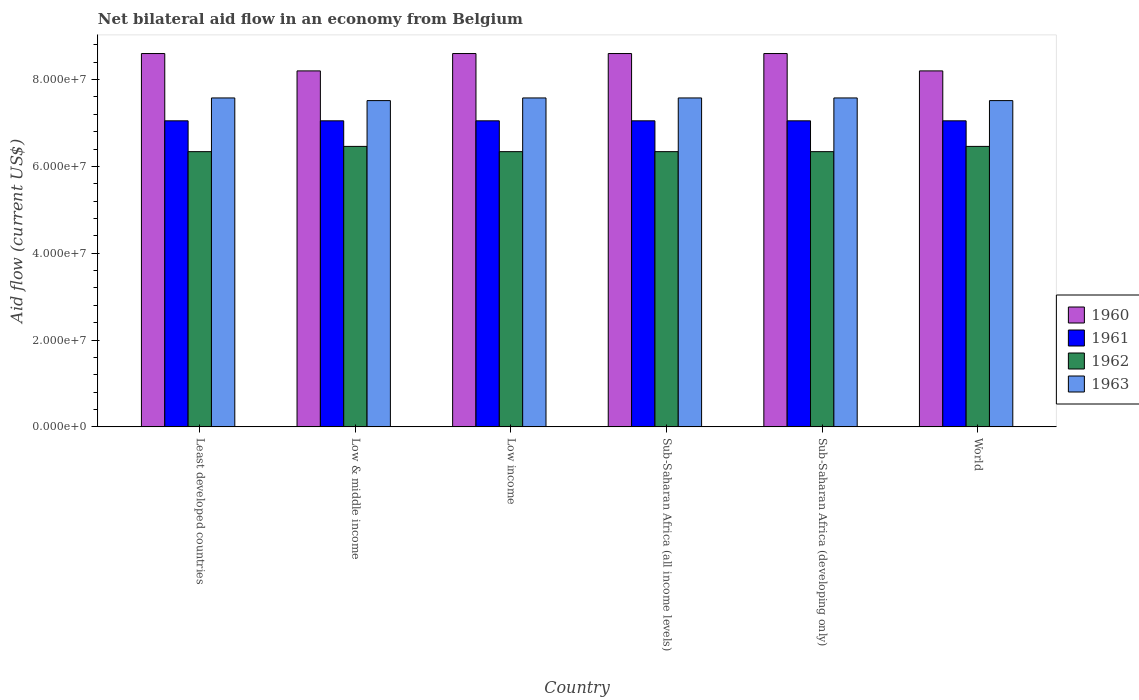Are the number of bars per tick equal to the number of legend labels?
Offer a terse response. Yes. Are the number of bars on each tick of the X-axis equal?
Ensure brevity in your answer.  Yes. How many bars are there on the 6th tick from the left?
Offer a very short reply. 4. How many bars are there on the 2nd tick from the right?
Provide a short and direct response. 4. What is the label of the 3rd group of bars from the left?
Provide a short and direct response. Low income. What is the net bilateral aid flow in 1962 in Least developed countries?
Provide a succinct answer. 6.34e+07. Across all countries, what is the maximum net bilateral aid flow in 1961?
Provide a short and direct response. 7.05e+07. Across all countries, what is the minimum net bilateral aid flow in 1960?
Your answer should be very brief. 8.20e+07. In which country was the net bilateral aid flow in 1960 maximum?
Your response must be concise. Least developed countries. In which country was the net bilateral aid flow in 1962 minimum?
Provide a short and direct response. Least developed countries. What is the total net bilateral aid flow in 1960 in the graph?
Offer a very short reply. 5.08e+08. What is the difference between the net bilateral aid flow in 1963 in Low income and the net bilateral aid flow in 1962 in Sub-Saharan Africa (developing only)?
Make the answer very short. 1.24e+07. What is the average net bilateral aid flow in 1961 per country?
Make the answer very short. 7.05e+07. What is the difference between the net bilateral aid flow of/in 1963 and net bilateral aid flow of/in 1960 in Sub-Saharan Africa (developing only)?
Ensure brevity in your answer.  -1.02e+07. What is the ratio of the net bilateral aid flow in 1963 in Low & middle income to that in Sub-Saharan Africa (all income levels)?
Ensure brevity in your answer.  0.99. Is the net bilateral aid flow in 1960 in Sub-Saharan Africa (all income levels) less than that in Sub-Saharan Africa (developing only)?
Give a very brief answer. No. What is the difference between the highest and the second highest net bilateral aid flow in 1962?
Offer a very short reply. 1.21e+06. What is the difference between the highest and the lowest net bilateral aid flow in 1963?
Keep it short and to the point. 6.10e+05. What does the 1st bar from the right in Sub-Saharan Africa (all income levels) represents?
Provide a short and direct response. 1963. How many bars are there?
Offer a very short reply. 24. Are all the bars in the graph horizontal?
Your response must be concise. No. Are the values on the major ticks of Y-axis written in scientific E-notation?
Offer a terse response. Yes. Does the graph contain any zero values?
Give a very brief answer. No. Where does the legend appear in the graph?
Your answer should be compact. Center right. How many legend labels are there?
Your response must be concise. 4. How are the legend labels stacked?
Keep it short and to the point. Vertical. What is the title of the graph?
Offer a terse response. Net bilateral aid flow in an economy from Belgium. What is the label or title of the Y-axis?
Keep it short and to the point. Aid flow (current US$). What is the Aid flow (current US$) in 1960 in Least developed countries?
Offer a very short reply. 8.60e+07. What is the Aid flow (current US$) of 1961 in Least developed countries?
Provide a short and direct response. 7.05e+07. What is the Aid flow (current US$) of 1962 in Least developed countries?
Your answer should be very brief. 6.34e+07. What is the Aid flow (current US$) of 1963 in Least developed countries?
Your answer should be compact. 7.58e+07. What is the Aid flow (current US$) of 1960 in Low & middle income?
Give a very brief answer. 8.20e+07. What is the Aid flow (current US$) in 1961 in Low & middle income?
Your answer should be compact. 7.05e+07. What is the Aid flow (current US$) of 1962 in Low & middle income?
Give a very brief answer. 6.46e+07. What is the Aid flow (current US$) in 1963 in Low & middle income?
Give a very brief answer. 7.52e+07. What is the Aid flow (current US$) of 1960 in Low income?
Give a very brief answer. 8.60e+07. What is the Aid flow (current US$) in 1961 in Low income?
Offer a very short reply. 7.05e+07. What is the Aid flow (current US$) of 1962 in Low income?
Your answer should be very brief. 6.34e+07. What is the Aid flow (current US$) in 1963 in Low income?
Make the answer very short. 7.58e+07. What is the Aid flow (current US$) in 1960 in Sub-Saharan Africa (all income levels)?
Ensure brevity in your answer.  8.60e+07. What is the Aid flow (current US$) in 1961 in Sub-Saharan Africa (all income levels)?
Provide a short and direct response. 7.05e+07. What is the Aid flow (current US$) of 1962 in Sub-Saharan Africa (all income levels)?
Provide a succinct answer. 6.34e+07. What is the Aid flow (current US$) of 1963 in Sub-Saharan Africa (all income levels)?
Provide a succinct answer. 7.58e+07. What is the Aid flow (current US$) of 1960 in Sub-Saharan Africa (developing only)?
Your response must be concise. 8.60e+07. What is the Aid flow (current US$) of 1961 in Sub-Saharan Africa (developing only)?
Provide a succinct answer. 7.05e+07. What is the Aid flow (current US$) in 1962 in Sub-Saharan Africa (developing only)?
Give a very brief answer. 6.34e+07. What is the Aid flow (current US$) of 1963 in Sub-Saharan Africa (developing only)?
Provide a succinct answer. 7.58e+07. What is the Aid flow (current US$) of 1960 in World?
Keep it short and to the point. 8.20e+07. What is the Aid flow (current US$) in 1961 in World?
Provide a short and direct response. 7.05e+07. What is the Aid flow (current US$) in 1962 in World?
Provide a succinct answer. 6.46e+07. What is the Aid flow (current US$) of 1963 in World?
Keep it short and to the point. 7.52e+07. Across all countries, what is the maximum Aid flow (current US$) in 1960?
Provide a short and direct response. 8.60e+07. Across all countries, what is the maximum Aid flow (current US$) of 1961?
Your response must be concise. 7.05e+07. Across all countries, what is the maximum Aid flow (current US$) in 1962?
Give a very brief answer. 6.46e+07. Across all countries, what is the maximum Aid flow (current US$) in 1963?
Provide a succinct answer. 7.58e+07. Across all countries, what is the minimum Aid flow (current US$) in 1960?
Provide a short and direct response. 8.20e+07. Across all countries, what is the minimum Aid flow (current US$) in 1961?
Your response must be concise. 7.05e+07. Across all countries, what is the minimum Aid flow (current US$) in 1962?
Keep it short and to the point. 6.34e+07. Across all countries, what is the minimum Aid flow (current US$) of 1963?
Make the answer very short. 7.52e+07. What is the total Aid flow (current US$) of 1960 in the graph?
Ensure brevity in your answer.  5.08e+08. What is the total Aid flow (current US$) of 1961 in the graph?
Keep it short and to the point. 4.23e+08. What is the total Aid flow (current US$) of 1962 in the graph?
Offer a terse response. 3.83e+08. What is the total Aid flow (current US$) of 1963 in the graph?
Your answer should be very brief. 4.53e+08. What is the difference between the Aid flow (current US$) in 1960 in Least developed countries and that in Low & middle income?
Your response must be concise. 4.00e+06. What is the difference between the Aid flow (current US$) of 1962 in Least developed countries and that in Low & middle income?
Your answer should be very brief. -1.21e+06. What is the difference between the Aid flow (current US$) in 1963 in Least developed countries and that in Low & middle income?
Ensure brevity in your answer.  6.10e+05. What is the difference between the Aid flow (current US$) of 1962 in Least developed countries and that in Low income?
Provide a succinct answer. 0. What is the difference between the Aid flow (current US$) in 1963 in Least developed countries and that in Low income?
Give a very brief answer. 0. What is the difference between the Aid flow (current US$) in 1961 in Least developed countries and that in Sub-Saharan Africa (all income levels)?
Your answer should be very brief. 0. What is the difference between the Aid flow (current US$) of 1962 in Least developed countries and that in Sub-Saharan Africa (all income levels)?
Ensure brevity in your answer.  0. What is the difference between the Aid flow (current US$) of 1963 in Least developed countries and that in Sub-Saharan Africa (all income levels)?
Offer a very short reply. 0. What is the difference between the Aid flow (current US$) of 1962 in Least developed countries and that in Sub-Saharan Africa (developing only)?
Offer a very short reply. 0. What is the difference between the Aid flow (current US$) in 1961 in Least developed countries and that in World?
Give a very brief answer. 0. What is the difference between the Aid flow (current US$) in 1962 in Least developed countries and that in World?
Offer a terse response. -1.21e+06. What is the difference between the Aid flow (current US$) of 1963 in Least developed countries and that in World?
Make the answer very short. 6.10e+05. What is the difference between the Aid flow (current US$) of 1962 in Low & middle income and that in Low income?
Offer a terse response. 1.21e+06. What is the difference between the Aid flow (current US$) in 1963 in Low & middle income and that in Low income?
Keep it short and to the point. -6.10e+05. What is the difference between the Aid flow (current US$) in 1960 in Low & middle income and that in Sub-Saharan Africa (all income levels)?
Your response must be concise. -4.00e+06. What is the difference between the Aid flow (current US$) in 1962 in Low & middle income and that in Sub-Saharan Africa (all income levels)?
Your answer should be very brief. 1.21e+06. What is the difference between the Aid flow (current US$) of 1963 in Low & middle income and that in Sub-Saharan Africa (all income levels)?
Offer a very short reply. -6.10e+05. What is the difference between the Aid flow (current US$) of 1960 in Low & middle income and that in Sub-Saharan Africa (developing only)?
Keep it short and to the point. -4.00e+06. What is the difference between the Aid flow (current US$) in 1962 in Low & middle income and that in Sub-Saharan Africa (developing only)?
Your answer should be very brief. 1.21e+06. What is the difference between the Aid flow (current US$) of 1963 in Low & middle income and that in Sub-Saharan Africa (developing only)?
Offer a terse response. -6.10e+05. What is the difference between the Aid flow (current US$) in 1960 in Low & middle income and that in World?
Your response must be concise. 0. What is the difference between the Aid flow (current US$) in 1961 in Low & middle income and that in World?
Your response must be concise. 0. What is the difference between the Aid flow (current US$) of 1962 in Low & middle income and that in World?
Ensure brevity in your answer.  0. What is the difference between the Aid flow (current US$) of 1961 in Low income and that in Sub-Saharan Africa (developing only)?
Keep it short and to the point. 0. What is the difference between the Aid flow (current US$) of 1960 in Low income and that in World?
Provide a short and direct response. 4.00e+06. What is the difference between the Aid flow (current US$) of 1961 in Low income and that in World?
Make the answer very short. 0. What is the difference between the Aid flow (current US$) of 1962 in Low income and that in World?
Your answer should be compact. -1.21e+06. What is the difference between the Aid flow (current US$) of 1963 in Low income and that in World?
Ensure brevity in your answer.  6.10e+05. What is the difference between the Aid flow (current US$) in 1962 in Sub-Saharan Africa (all income levels) and that in Sub-Saharan Africa (developing only)?
Keep it short and to the point. 0. What is the difference between the Aid flow (current US$) in 1960 in Sub-Saharan Africa (all income levels) and that in World?
Keep it short and to the point. 4.00e+06. What is the difference between the Aid flow (current US$) of 1961 in Sub-Saharan Africa (all income levels) and that in World?
Provide a succinct answer. 0. What is the difference between the Aid flow (current US$) of 1962 in Sub-Saharan Africa (all income levels) and that in World?
Keep it short and to the point. -1.21e+06. What is the difference between the Aid flow (current US$) in 1963 in Sub-Saharan Africa (all income levels) and that in World?
Make the answer very short. 6.10e+05. What is the difference between the Aid flow (current US$) of 1960 in Sub-Saharan Africa (developing only) and that in World?
Keep it short and to the point. 4.00e+06. What is the difference between the Aid flow (current US$) in 1962 in Sub-Saharan Africa (developing only) and that in World?
Your response must be concise. -1.21e+06. What is the difference between the Aid flow (current US$) of 1960 in Least developed countries and the Aid flow (current US$) of 1961 in Low & middle income?
Give a very brief answer. 1.55e+07. What is the difference between the Aid flow (current US$) of 1960 in Least developed countries and the Aid flow (current US$) of 1962 in Low & middle income?
Offer a terse response. 2.14e+07. What is the difference between the Aid flow (current US$) in 1960 in Least developed countries and the Aid flow (current US$) in 1963 in Low & middle income?
Your answer should be compact. 1.08e+07. What is the difference between the Aid flow (current US$) in 1961 in Least developed countries and the Aid flow (current US$) in 1962 in Low & middle income?
Ensure brevity in your answer.  5.89e+06. What is the difference between the Aid flow (current US$) in 1961 in Least developed countries and the Aid flow (current US$) in 1963 in Low & middle income?
Offer a terse response. -4.66e+06. What is the difference between the Aid flow (current US$) of 1962 in Least developed countries and the Aid flow (current US$) of 1963 in Low & middle income?
Make the answer very short. -1.18e+07. What is the difference between the Aid flow (current US$) of 1960 in Least developed countries and the Aid flow (current US$) of 1961 in Low income?
Your answer should be compact. 1.55e+07. What is the difference between the Aid flow (current US$) of 1960 in Least developed countries and the Aid flow (current US$) of 1962 in Low income?
Offer a very short reply. 2.26e+07. What is the difference between the Aid flow (current US$) of 1960 in Least developed countries and the Aid flow (current US$) of 1963 in Low income?
Provide a short and direct response. 1.02e+07. What is the difference between the Aid flow (current US$) of 1961 in Least developed countries and the Aid flow (current US$) of 1962 in Low income?
Your answer should be very brief. 7.10e+06. What is the difference between the Aid flow (current US$) in 1961 in Least developed countries and the Aid flow (current US$) in 1963 in Low income?
Your answer should be compact. -5.27e+06. What is the difference between the Aid flow (current US$) of 1962 in Least developed countries and the Aid flow (current US$) of 1963 in Low income?
Your answer should be compact. -1.24e+07. What is the difference between the Aid flow (current US$) in 1960 in Least developed countries and the Aid flow (current US$) in 1961 in Sub-Saharan Africa (all income levels)?
Your response must be concise. 1.55e+07. What is the difference between the Aid flow (current US$) of 1960 in Least developed countries and the Aid flow (current US$) of 1962 in Sub-Saharan Africa (all income levels)?
Make the answer very short. 2.26e+07. What is the difference between the Aid flow (current US$) of 1960 in Least developed countries and the Aid flow (current US$) of 1963 in Sub-Saharan Africa (all income levels)?
Keep it short and to the point. 1.02e+07. What is the difference between the Aid flow (current US$) in 1961 in Least developed countries and the Aid flow (current US$) in 1962 in Sub-Saharan Africa (all income levels)?
Ensure brevity in your answer.  7.10e+06. What is the difference between the Aid flow (current US$) of 1961 in Least developed countries and the Aid flow (current US$) of 1963 in Sub-Saharan Africa (all income levels)?
Keep it short and to the point. -5.27e+06. What is the difference between the Aid flow (current US$) of 1962 in Least developed countries and the Aid flow (current US$) of 1963 in Sub-Saharan Africa (all income levels)?
Give a very brief answer. -1.24e+07. What is the difference between the Aid flow (current US$) of 1960 in Least developed countries and the Aid flow (current US$) of 1961 in Sub-Saharan Africa (developing only)?
Provide a short and direct response. 1.55e+07. What is the difference between the Aid flow (current US$) in 1960 in Least developed countries and the Aid flow (current US$) in 1962 in Sub-Saharan Africa (developing only)?
Offer a terse response. 2.26e+07. What is the difference between the Aid flow (current US$) in 1960 in Least developed countries and the Aid flow (current US$) in 1963 in Sub-Saharan Africa (developing only)?
Provide a short and direct response. 1.02e+07. What is the difference between the Aid flow (current US$) in 1961 in Least developed countries and the Aid flow (current US$) in 1962 in Sub-Saharan Africa (developing only)?
Provide a short and direct response. 7.10e+06. What is the difference between the Aid flow (current US$) of 1961 in Least developed countries and the Aid flow (current US$) of 1963 in Sub-Saharan Africa (developing only)?
Your answer should be compact. -5.27e+06. What is the difference between the Aid flow (current US$) of 1962 in Least developed countries and the Aid flow (current US$) of 1963 in Sub-Saharan Africa (developing only)?
Offer a very short reply. -1.24e+07. What is the difference between the Aid flow (current US$) of 1960 in Least developed countries and the Aid flow (current US$) of 1961 in World?
Ensure brevity in your answer.  1.55e+07. What is the difference between the Aid flow (current US$) in 1960 in Least developed countries and the Aid flow (current US$) in 1962 in World?
Make the answer very short. 2.14e+07. What is the difference between the Aid flow (current US$) in 1960 in Least developed countries and the Aid flow (current US$) in 1963 in World?
Provide a succinct answer. 1.08e+07. What is the difference between the Aid flow (current US$) in 1961 in Least developed countries and the Aid flow (current US$) in 1962 in World?
Provide a short and direct response. 5.89e+06. What is the difference between the Aid flow (current US$) of 1961 in Least developed countries and the Aid flow (current US$) of 1963 in World?
Ensure brevity in your answer.  -4.66e+06. What is the difference between the Aid flow (current US$) of 1962 in Least developed countries and the Aid flow (current US$) of 1963 in World?
Keep it short and to the point. -1.18e+07. What is the difference between the Aid flow (current US$) of 1960 in Low & middle income and the Aid flow (current US$) of 1961 in Low income?
Provide a short and direct response. 1.15e+07. What is the difference between the Aid flow (current US$) of 1960 in Low & middle income and the Aid flow (current US$) of 1962 in Low income?
Your answer should be very brief. 1.86e+07. What is the difference between the Aid flow (current US$) in 1960 in Low & middle income and the Aid flow (current US$) in 1963 in Low income?
Provide a short and direct response. 6.23e+06. What is the difference between the Aid flow (current US$) of 1961 in Low & middle income and the Aid flow (current US$) of 1962 in Low income?
Provide a short and direct response. 7.10e+06. What is the difference between the Aid flow (current US$) in 1961 in Low & middle income and the Aid flow (current US$) in 1963 in Low income?
Ensure brevity in your answer.  -5.27e+06. What is the difference between the Aid flow (current US$) of 1962 in Low & middle income and the Aid flow (current US$) of 1963 in Low income?
Your response must be concise. -1.12e+07. What is the difference between the Aid flow (current US$) of 1960 in Low & middle income and the Aid flow (current US$) of 1961 in Sub-Saharan Africa (all income levels)?
Give a very brief answer. 1.15e+07. What is the difference between the Aid flow (current US$) in 1960 in Low & middle income and the Aid flow (current US$) in 1962 in Sub-Saharan Africa (all income levels)?
Your answer should be very brief. 1.86e+07. What is the difference between the Aid flow (current US$) in 1960 in Low & middle income and the Aid flow (current US$) in 1963 in Sub-Saharan Africa (all income levels)?
Your response must be concise. 6.23e+06. What is the difference between the Aid flow (current US$) in 1961 in Low & middle income and the Aid flow (current US$) in 1962 in Sub-Saharan Africa (all income levels)?
Give a very brief answer. 7.10e+06. What is the difference between the Aid flow (current US$) of 1961 in Low & middle income and the Aid flow (current US$) of 1963 in Sub-Saharan Africa (all income levels)?
Ensure brevity in your answer.  -5.27e+06. What is the difference between the Aid flow (current US$) of 1962 in Low & middle income and the Aid flow (current US$) of 1963 in Sub-Saharan Africa (all income levels)?
Keep it short and to the point. -1.12e+07. What is the difference between the Aid flow (current US$) in 1960 in Low & middle income and the Aid flow (current US$) in 1961 in Sub-Saharan Africa (developing only)?
Keep it short and to the point. 1.15e+07. What is the difference between the Aid flow (current US$) in 1960 in Low & middle income and the Aid flow (current US$) in 1962 in Sub-Saharan Africa (developing only)?
Provide a short and direct response. 1.86e+07. What is the difference between the Aid flow (current US$) of 1960 in Low & middle income and the Aid flow (current US$) of 1963 in Sub-Saharan Africa (developing only)?
Make the answer very short. 6.23e+06. What is the difference between the Aid flow (current US$) in 1961 in Low & middle income and the Aid flow (current US$) in 1962 in Sub-Saharan Africa (developing only)?
Offer a very short reply. 7.10e+06. What is the difference between the Aid flow (current US$) of 1961 in Low & middle income and the Aid flow (current US$) of 1963 in Sub-Saharan Africa (developing only)?
Give a very brief answer. -5.27e+06. What is the difference between the Aid flow (current US$) in 1962 in Low & middle income and the Aid flow (current US$) in 1963 in Sub-Saharan Africa (developing only)?
Provide a succinct answer. -1.12e+07. What is the difference between the Aid flow (current US$) of 1960 in Low & middle income and the Aid flow (current US$) of 1961 in World?
Your answer should be compact. 1.15e+07. What is the difference between the Aid flow (current US$) of 1960 in Low & middle income and the Aid flow (current US$) of 1962 in World?
Provide a succinct answer. 1.74e+07. What is the difference between the Aid flow (current US$) in 1960 in Low & middle income and the Aid flow (current US$) in 1963 in World?
Your answer should be very brief. 6.84e+06. What is the difference between the Aid flow (current US$) in 1961 in Low & middle income and the Aid flow (current US$) in 1962 in World?
Provide a short and direct response. 5.89e+06. What is the difference between the Aid flow (current US$) in 1961 in Low & middle income and the Aid flow (current US$) in 1963 in World?
Make the answer very short. -4.66e+06. What is the difference between the Aid flow (current US$) of 1962 in Low & middle income and the Aid flow (current US$) of 1963 in World?
Make the answer very short. -1.06e+07. What is the difference between the Aid flow (current US$) of 1960 in Low income and the Aid flow (current US$) of 1961 in Sub-Saharan Africa (all income levels)?
Provide a succinct answer. 1.55e+07. What is the difference between the Aid flow (current US$) of 1960 in Low income and the Aid flow (current US$) of 1962 in Sub-Saharan Africa (all income levels)?
Your answer should be very brief. 2.26e+07. What is the difference between the Aid flow (current US$) in 1960 in Low income and the Aid flow (current US$) in 1963 in Sub-Saharan Africa (all income levels)?
Make the answer very short. 1.02e+07. What is the difference between the Aid flow (current US$) in 1961 in Low income and the Aid flow (current US$) in 1962 in Sub-Saharan Africa (all income levels)?
Your answer should be compact. 7.10e+06. What is the difference between the Aid flow (current US$) of 1961 in Low income and the Aid flow (current US$) of 1963 in Sub-Saharan Africa (all income levels)?
Your answer should be very brief. -5.27e+06. What is the difference between the Aid flow (current US$) in 1962 in Low income and the Aid flow (current US$) in 1963 in Sub-Saharan Africa (all income levels)?
Offer a very short reply. -1.24e+07. What is the difference between the Aid flow (current US$) in 1960 in Low income and the Aid flow (current US$) in 1961 in Sub-Saharan Africa (developing only)?
Offer a terse response. 1.55e+07. What is the difference between the Aid flow (current US$) in 1960 in Low income and the Aid flow (current US$) in 1962 in Sub-Saharan Africa (developing only)?
Provide a short and direct response. 2.26e+07. What is the difference between the Aid flow (current US$) in 1960 in Low income and the Aid flow (current US$) in 1963 in Sub-Saharan Africa (developing only)?
Offer a very short reply. 1.02e+07. What is the difference between the Aid flow (current US$) of 1961 in Low income and the Aid flow (current US$) of 1962 in Sub-Saharan Africa (developing only)?
Give a very brief answer. 7.10e+06. What is the difference between the Aid flow (current US$) in 1961 in Low income and the Aid flow (current US$) in 1963 in Sub-Saharan Africa (developing only)?
Your answer should be very brief. -5.27e+06. What is the difference between the Aid flow (current US$) in 1962 in Low income and the Aid flow (current US$) in 1963 in Sub-Saharan Africa (developing only)?
Give a very brief answer. -1.24e+07. What is the difference between the Aid flow (current US$) in 1960 in Low income and the Aid flow (current US$) in 1961 in World?
Your response must be concise. 1.55e+07. What is the difference between the Aid flow (current US$) in 1960 in Low income and the Aid flow (current US$) in 1962 in World?
Offer a very short reply. 2.14e+07. What is the difference between the Aid flow (current US$) of 1960 in Low income and the Aid flow (current US$) of 1963 in World?
Your answer should be compact. 1.08e+07. What is the difference between the Aid flow (current US$) in 1961 in Low income and the Aid flow (current US$) in 1962 in World?
Give a very brief answer. 5.89e+06. What is the difference between the Aid flow (current US$) in 1961 in Low income and the Aid flow (current US$) in 1963 in World?
Make the answer very short. -4.66e+06. What is the difference between the Aid flow (current US$) in 1962 in Low income and the Aid flow (current US$) in 1963 in World?
Make the answer very short. -1.18e+07. What is the difference between the Aid flow (current US$) in 1960 in Sub-Saharan Africa (all income levels) and the Aid flow (current US$) in 1961 in Sub-Saharan Africa (developing only)?
Give a very brief answer. 1.55e+07. What is the difference between the Aid flow (current US$) in 1960 in Sub-Saharan Africa (all income levels) and the Aid flow (current US$) in 1962 in Sub-Saharan Africa (developing only)?
Your response must be concise. 2.26e+07. What is the difference between the Aid flow (current US$) of 1960 in Sub-Saharan Africa (all income levels) and the Aid flow (current US$) of 1963 in Sub-Saharan Africa (developing only)?
Your answer should be very brief. 1.02e+07. What is the difference between the Aid flow (current US$) in 1961 in Sub-Saharan Africa (all income levels) and the Aid flow (current US$) in 1962 in Sub-Saharan Africa (developing only)?
Provide a short and direct response. 7.10e+06. What is the difference between the Aid flow (current US$) in 1961 in Sub-Saharan Africa (all income levels) and the Aid flow (current US$) in 1963 in Sub-Saharan Africa (developing only)?
Offer a terse response. -5.27e+06. What is the difference between the Aid flow (current US$) in 1962 in Sub-Saharan Africa (all income levels) and the Aid flow (current US$) in 1963 in Sub-Saharan Africa (developing only)?
Make the answer very short. -1.24e+07. What is the difference between the Aid flow (current US$) in 1960 in Sub-Saharan Africa (all income levels) and the Aid flow (current US$) in 1961 in World?
Provide a short and direct response. 1.55e+07. What is the difference between the Aid flow (current US$) in 1960 in Sub-Saharan Africa (all income levels) and the Aid flow (current US$) in 1962 in World?
Your answer should be compact. 2.14e+07. What is the difference between the Aid flow (current US$) of 1960 in Sub-Saharan Africa (all income levels) and the Aid flow (current US$) of 1963 in World?
Give a very brief answer. 1.08e+07. What is the difference between the Aid flow (current US$) of 1961 in Sub-Saharan Africa (all income levels) and the Aid flow (current US$) of 1962 in World?
Your response must be concise. 5.89e+06. What is the difference between the Aid flow (current US$) in 1961 in Sub-Saharan Africa (all income levels) and the Aid flow (current US$) in 1963 in World?
Provide a succinct answer. -4.66e+06. What is the difference between the Aid flow (current US$) of 1962 in Sub-Saharan Africa (all income levels) and the Aid flow (current US$) of 1963 in World?
Provide a short and direct response. -1.18e+07. What is the difference between the Aid flow (current US$) of 1960 in Sub-Saharan Africa (developing only) and the Aid flow (current US$) of 1961 in World?
Provide a succinct answer. 1.55e+07. What is the difference between the Aid flow (current US$) in 1960 in Sub-Saharan Africa (developing only) and the Aid flow (current US$) in 1962 in World?
Offer a very short reply. 2.14e+07. What is the difference between the Aid flow (current US$) of 1960 in Sub-Saharan Africa (developing only) and the Aid flow (current US$) of 1963 in World?
Offer a terse response. 1.08e+07. What is the difference between the Aid flow (current US$) of 1961 in Sub-Saharan Africa (developing only) and the Aid flow (current US$) of 1962 in World?
Your answer should be compact. 5.89e+06. What is the difference between the Aid flow (current US$) in 1961 in Sub-Saharan Africa (developing only) and the Aid flow (current US$) in 1963 in World?
Keep it short and to the point. -4.66e+06. What is the difference between the Aid flow (current US$) in 1962 in Sub-Saharan Africa (developing only) and the Aid flow (current US$) in 1963 in World?
Provide a short and direct response. -1.18e+07. What is the average Aid flow (current US$) of 1960 per country?
Ensure brevity in your answer.  8.47e+07. What is the average Aid flow (current US$) of 1961 per country?
Provide a short and direct response. 7.05e+07. What is the average Aid flow (current US$) in 1962 per country?
Ensure brevity in your answer.  6.38e+07. What is the average Aid flow (current US$) of 1963 per country?
Make the answer very short. 7.56e+07. What is the difference between the Aid flow (current US$) of 1960 and Aid flow (current US$) of 1961 in Least developed countries?
Ensure brevity in your answer.  1.55e+07. What is the difference between the Aid flow (current US$) of 1960 and Aid flow (current US$) of 1962 in Least developed countries?
Give a very brief answer. 2.26e+07. What is the difference between the Aid flow (current US$) of 1960 and Aid flow (current US$) of 1963 in Least developed countries?
Offer a terse response. 1.02e+07. What is the difference between the Aid flow (current US$) of 1961 and Aid flow (current US$) of 1962 in Least developed countries?
Provide a short and direct response. 7.10e+06. What is the difference between the Aid flow (current US$) in 1961 and Aid flow (current US$) in 1963 in Least developed countries?
Offer a terse response. -5.27e+06. What is the difference between the Aid flow (current US$) in 1962 and Aid flow (current US$) in 1963 in Least developed countries?
Your response must be concise. -1.24e+07. What is the difference between the Aid flow (current US$) of 1960 and Aid flow (current US$) of 1961 in Low & middle income?
Ensure brevity in your answer.  1.15e+07. What is the difference between the Aid flow (current US$) of 1960 and Aid flow (current US$) of 1962 in Low & middle income?
Offer a very short reply. 1.74e+07. What is the difference between the Aid flow (current US$) of 1960 and Aid flow (current US$) of 1963 in Low & middle income?
Make the answer very short. 6.84e+06. What is the difference between the Aid flow (current US$) in 1961 and Aid flow (current US$) in 1962 in Low & middle income?
Offer a terse response. 5.89e+06. What is the difference between the Aid flow (current US$) in 1961 and Aid flow (current US$) in 1963 in Low & middle income?
Provide a short and direct response. -4.66e+06. What is the difference between the Aid flow (current US$) in 1962 and Aid flow (current US$) in 1963 in Low & middle income?
Ensure brevity in your answer.  -1.06e+07. What is the difference between the Aid flow (current US$) in 1960 and Aid flow (current US$) in 1961 in Low income?
Provide a short and direct response. 1.55e+07. What is the difference between the Aid flow (current US$) in 1960 and Aid flow (current US$) in 1962 in Low income?
Keep it short and to the point. 2.26e+07. What is the difference between the Aid flow (current US$) in 1960 and Aid flow (current US$) in 1963 in Low income?
Give a very brief answer. 1.02e+07. What is the difference between the Aid flow (current US$) in 1961 and Aid flow (current US$) in 1962 in Low income?
Give a very brief answer. 7.10e+06. What is the difference between the Aid flow (current US$) in 1961 and Aid flow (current US$) in 1963 in Low income?
Keep it short and to the point. -5.27e+06. What is the difference between the Aid flow (current US$) in 1962 and Aid flow (current US$) in 1963 in Low income?
Your answer should be very brief. -1.24e+07. What is the difference between the Aid flow (current US$) in 1960 and Aid flow (current US$) in 1961 in Sub-Saharan Africa (all income levels)?
Keep it short and to the point. 1.55e+07. What is the difference between the Aid flow (current US$) in 1960 and Aid flow (current US$) in 1962 in Sub-Saharan Africa (all income levels)?
Your answer should be compact. 2.26e+07. What is the difference between the Aid flow (current US$) of 1960 and Aid flow (current US$) of 1963 in Sub-Saharan Africa (all income levels)?
Ensure brevity in your answer.  1.02e+07. What is the difference between the Aid flow (current US$) of 1961 and Aid flow (current US$) of 1962 in Sub-Saharan Africa (all income levels)?
Keep it short and to the point. 7.10e+06. What is the difference between the Aid flow (current US$) of 1961 and Aid flow (current US$) of 1963 in Sub-Saharan Africa (all income levels)?
Your answer should be very brief. -5.27e+06. What is the difference between the Aid flow (current US$) of 1962 and Aid flow (current US$) of 1963 in Sub-Saharan Africa (all income levels)?
Keep it short and to the point. -1.24e+07. What is the difference between the Aid flow (current US$) in 1960 and Aid flow (current US$) in 1961 in Sub-Saharan Africa (developing only)?
Your answer should be very brief. 1.55e+07. What is the difference between the Aid flow (current US$) in 1960 and Aid flow (current US$) in 1962 in Sub-Saharan Africa (developing only)?
Give a very brief answer. 2.26e+07. What is the difference between the Aid flow (current US$) in 1960 and Aid flow (current US$) in 1963 in Sub-Saharan Africa (developing only)?
Provide a short and direct response. 1.02e+07. What is the difference between the Aid flow (current US$) of 1961 and Aid flow (current US$) of 1962 in Sub-Saharan Africa (developing only)?
Ensure brevity in your answer.  7.10e+06. What is the difference between the Aid flow (current US$) in 1961 and Aid flow (current US$) in 1963 in Sub-Saharan Africa (developing only)?
Ensure brevity in your answer.  -5.27e+06. What is the difference between the Aid flow (current US$) in 1962 and Aid flow (current US$) in 1963 in Sub-Saharan Africa (developing only)?
Provide a succinct answer. -1.24e+07. What is the difference between the Aid flow (current US$) in 1960 and Aid flow (current US$) in 1961 in World?
Your answer should be very brief. 1.15e+07. What is the difference between the Aid flow (current US$) of 1960 and Aid flow (current US$) of 1962 in World?
Your answer should be compact. 1.74e+07. What is the difference between the Aid flow (current US$) in 1960 and Aid flow (current US$) in 1963 in World?
Offer a very short reply. 6.84e+06. What is the difference between the Aid flow (current US$) in 1961 and Aid flow (current US$) in 1962 in World?
Your answer should be compact. 5.89e+06. What is the difference between the Aid flow (current US$) of 1961 and Aid flow (current US$) of 1963 in World?
Your answer should be compact. -4.66e+06. What is the difference between the Aid flow (current US$) in 1962 and Aid flow (current US$) in 1963 in World?
Your answer should be compact. -1.06e+07. What is the ratio of the Aid flow (current US$) in 1960 in Least developed countries to that in Low & middle income?
Offer a terse response. 1.05. What is the ratio of the Aid flow (current US$) of 1962 in Least developed countries to that in Low & middle income?
Your answer should be very brief. 0.98. What is the ratio of the Aid flow (current US$) of 1961 in Least developed countries to that in Low income?
Offer a very short reply. 1. What is the ratio of the Aid flow (current US$) of 1962 in Least developed countries to that in Low income?
Provide a short and direct response. 1. What is the ratio of the Aid flow (current US$) of 1963 in Least developed countries to that in Low income?
Make the answer very short. 1. What is the ratio of the Aid flow (current US$) in 1961 in Least developed countries to that in Sub-Saharan Africa (all income levels)?
Offer a terse response. 1. What is the ratio of the Aid flow (current US$) of 1962 in Least developed countries to that in Sub-Saharan Africa (all income levels)?
Your answer should be very brief. 1. What is the ratio of the Aid flow (current US$) in 1960 in Least developed countries to that in Sub-Saharan Africa (developing only)?
Your response must be concise. 1. What is the ratio of the Aid flow (current US$) of 1961 in Least developed countries to that in Sub-Saharan Africa (developing only)?
Provide a succinct answer. 1. What is the ratio of the Aid flow (current US$) of 1962 in Least developed countries to that in Sub-Saharan Africa (developing only)?
Your response must be concise. 1. What is the ratio of the Aid flow (current US$) in 1963 in Least developed countries to that in Sub-Saharan Africa (developing only)?
Make the answer very short. 1. What is the ratio of the Aid flow (current US$) in 1960 in Least developed countries to that in World?
Make the answer very short. 1.05. What is the ratio of the Aid flow (current US$) in 1962 in Least developed countries to that in World?
Make the answer very short. 0.98. What is the ratio of the Aid flow (current US$) in 1963 in Least developed countries to that in World?
Make the answer very short. 1.01. What is the ratio of the Aid flow (current US$) in 1960 in Low & middle income to that in Low income?
Give a very brief answer. 0.95. What is the ratio of the Aid flow (current US$) of 1962 in Low & middle income to that in Low income?
Give a very brief answer. 1.02. What is the ratio of the Aid flow (current US$) of 1960 in Low & middle income to that in Sub-Saharan Africa (all income levels)?
Your response must be concise. 0.95. What is the ratio of the Aid flow (current US$) in 1961 in Low & middle income to that in Sub-Saharan Africa (all income levels)?
Your answer should be compact. 1. What is the ratio of the Aid flow (current US$) in 1962 in Low & middle income to that in Sub-Saharan Africa (all income levels)?
Provide a short and direct response. 1.02. What is the ratio of the Aid flow (current US$) in 1963 in Low & middle income to that in Sub-Saharan Africa (all income levels)?
Your answer should be very brief. 0.99. What is the ratio of the Aid flow (current US$) of 1960 in Low & middle income to that in Sub-Saharan Africa (developing only)?
Make the answer very short. 0.95. What is the ratio of the Aid flow (current US$) in 1961 in Low & middle income to that in Sub-Saharan Africa (developing only)?
Keep it short and to the point. 1. What is the ratio of the Aid flow (current US$) of 1962 in Low & middle income to that in Sub-Saharan Africa (developing only)?
Provide a short and direct response. 1.02. What is the ratio of the Aid flow (current US$) of 1962 in Low & middle income to that in World?
Your answer should be very brief. 1. What is the ratio of the Aid flow (current US$) in 1960 in Low income to that in Sub-Saharan Africa (all income levels)?
Keep it short and to the point. 1. What is the ratio of the Aid flow (current US$) of 1962 in Low income to that in Sub-Saharan Africa (all income levels)?
Ensure brevity in your answer.  1. What is the ratio of the Aid flow (current US$) in 1963 in Low income to that in Sub-Saharan Africa (all income levels)?
Keep it short and to the point. 1. What is the ratio of the Aid flow (current US$) of 1961 in Low income to that in Sub-Saharan Africa (developing only)?
Your answer should be compact. 1. What is the ratio of the Aid flow (current US$) of 1960 in Low income to that in World?
Keep it short and to the point. 1.05. What is the ratio of the Aid flow (current US$) of 1962 in Low income to that in World?
Give a very brief answer. 0.98. What is the ratio of the Aid flow (current US$) in 1963 in Low income to that in World?
Your answer should be very brief. 1.01. What is the ratio of the Aid flow (current US$) in 1962 in Sub-Saharan Africa (all income levels) to that in Sub-Saharan Africa (developing only)?
Offer a very short reply. 1. What is the ratio of the Aid flow (current US$) of 1963 in Sub-Saharan Africa (all income levels) to that in Sub-Saharan Africa (developing only)?
Provide a short and direct response. 1. What is the ratio of the Aid flow (current US$) of 1960 in Sub-Saharan Africa (all income levels) to that in World?
Give a very brief answer. 1.05. What is the ratio of the Aid flow (current US$) of 1962 in Sub-Saharan Africa (all income levels) to that in World?
Offer a terse response. 0.98. What is the ratio of the Aid flow (current US$) in 1963 in Sub-Saharan Africa (all income levels) to that in World?
Your response must be concise. 1.01. What is the ratio of the Aid flow (current US$) of 1960 in Sub-Saharan Africa (developing only) to that in World?
Give a very brief answer. 1.05. What is the ratio of the Aid flow (current US$) of 1961 in Sub-Saharan Africa (developing only) to that in World?
Keep it short and to the point. 1. What is the ratio of the Aid flow (current US$) of 1962 in Sub-Saharan Africa (developing only) to that in World?
Your response must be concise. 0.98. What is the ratio of the Aid flow (current US$) in 1963 in Sub-Saharan Africa (developing only) to that in World?
Offer a very short reply. 1.01. What is the difference between the highest and the second highest Aid flow (current US$) of 1961?
Your answer should be compact. 0. What is the difference between the highest and the lowest Aid flow (current US$) of 1960?
Keep it short and to the point. 4.00e+06. What is the difference between the highest and the lowest Aid flow (current US$) in 1961?
Provide a succinct answer. 0. What is the difference between the highest and the lowest Aid flow (current US$) of 1962?
Offer a terse response. 1.21e+06. What is the difference between the highest and the lowest Aid flow (current US$) in 1963?
Give a very brief answer. 6.10e+05. 